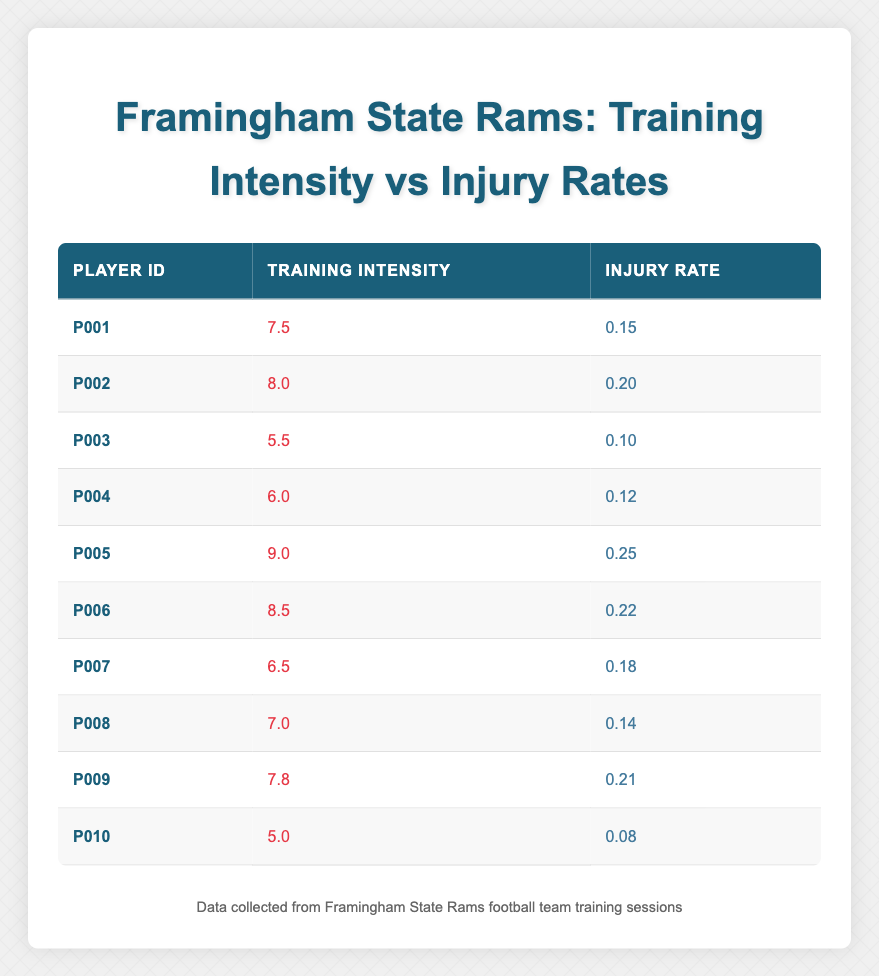What is the training intensity of player P005? The table shows that under the "Training Intensity" column, P005 has a value of 9.0.
Answer: 9.0 What is the injury rate of player P010? From the table, the "Injury Rate" for player P010 is listed as 0.08.
Answer: 0.08 Which player has the highest injury rate and what is that rate? P005 has the highest injury rate listed in the table at 0.25.
Answer: P005, 0.25 What is the average training intensity of the players? To find the average, add all training intensities: (7.5 + 8.0 + 5.5 + 6.0 + 9.0 + 8.5 + 6.5 + 7.0 + 7.8 + 5.0) = 69.8 and divide by the number of players (10): 69.8 / 10 = 6.98.
Answer: 6.98 Is the injury rate for player P003 lower than 0.15? The injury rate for P003 is 0.10, which is lower than 0.15.
Answer: Yes What is the difference between the highest and the lowest training intensity? The highest training intensity is from P005 at 9.0 and the lowest is from P010 at 5.0. The difference is 9.0 - 5.0 = 4.0.
Answer: 4.0 Which players have an injury rate above 0.20? The players with injury rates above 0.20 are P005 (0.25) and P006 (0.22).
Answer: P005, P006 How many players have a training intensity of 7.5 or higher? Counting from the table, the players with a training intensity of 7.5 or higher are P001, P002, P005, P006, P009, which makes a total of 5 players.
Answer: 5 What is the correlation between training intensity and injury rate based on the table? While the table does not explicitly show correlation values, a visual observation suggests that as training intensity increases, injury rates tend to increase as well, indicating a potential positive correlation.
Answer: Potentially positive correlation 